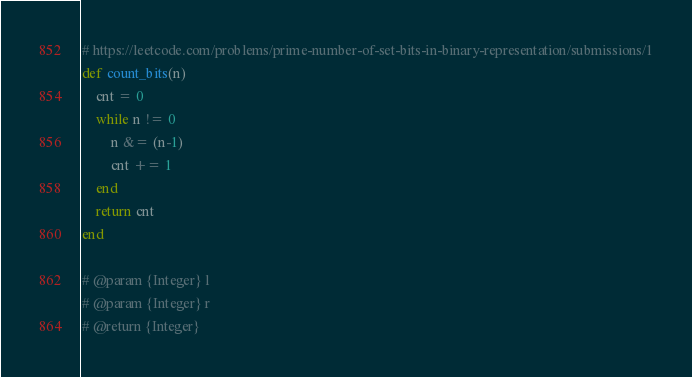<code> <loc_0><loc_0><loc_500><loc_500><_Ruby_># https://leetcode.com/problems/prime-number-of-set-bits-in-binary-representation/submissions/1
def count_bits(n)
    cnt = 0
    while n != 0
        n &= (n-1)
        cnt += 1
    end
    return cnt
end

# @param {Integer} l
# @param {Integer} r
# @return {Integer}</code> 